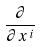<formula> <loc_0><loc_0><loc_500><loc_500>\frac { \partial } { \partial x ^ { i } }</formula> 